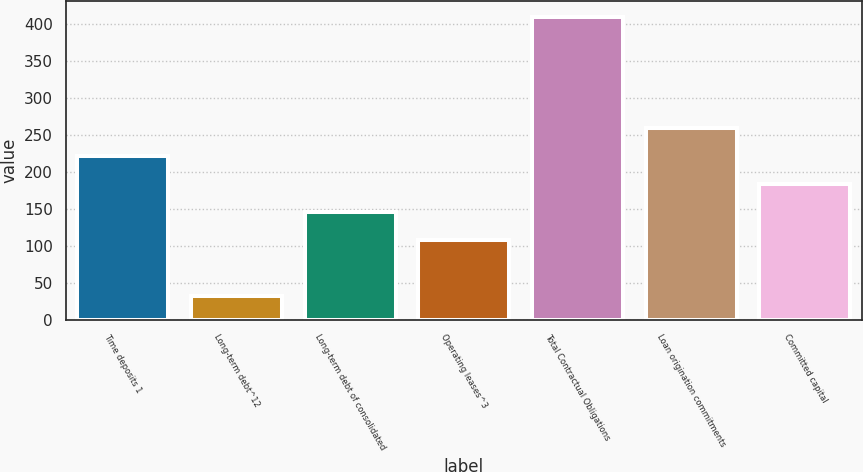Convert chart to OTSL. <chart><loc_0><loc_0><loc_500><loc_500><bar_chart><fcel>Time deposits 1<fcel>Long-term debt^12<fcel>Long-term debt of consolidated<fcel>Operating leases^3<fcel>Total Contractual Obligations<fcel>Loan origination commitments<fcel>Committed capital<nl><fcel>221.05<fcel>32.3<fcel>145.55<fcel>107.8<fcel>409.8<fcel>258.8<fcel>183.3<nl></chart> 